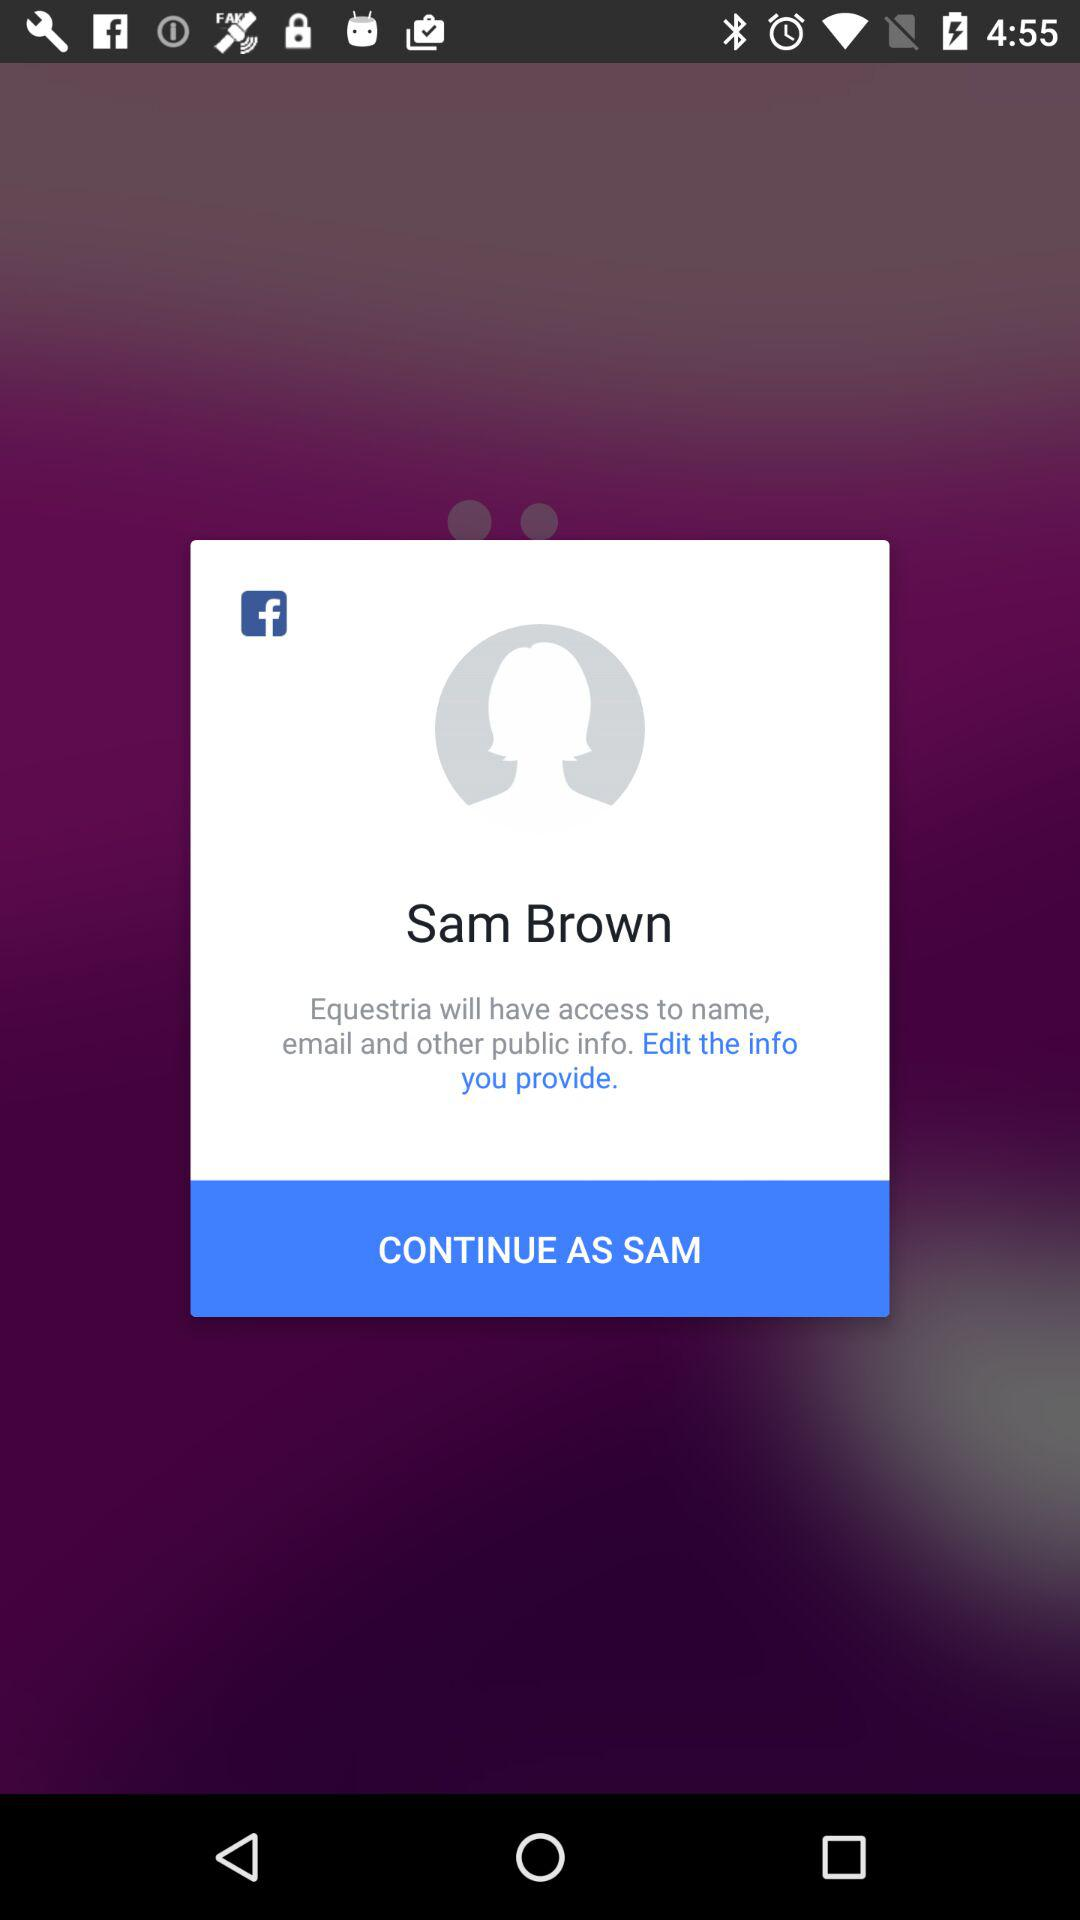What is the user name? The user name is Sam Brown. 